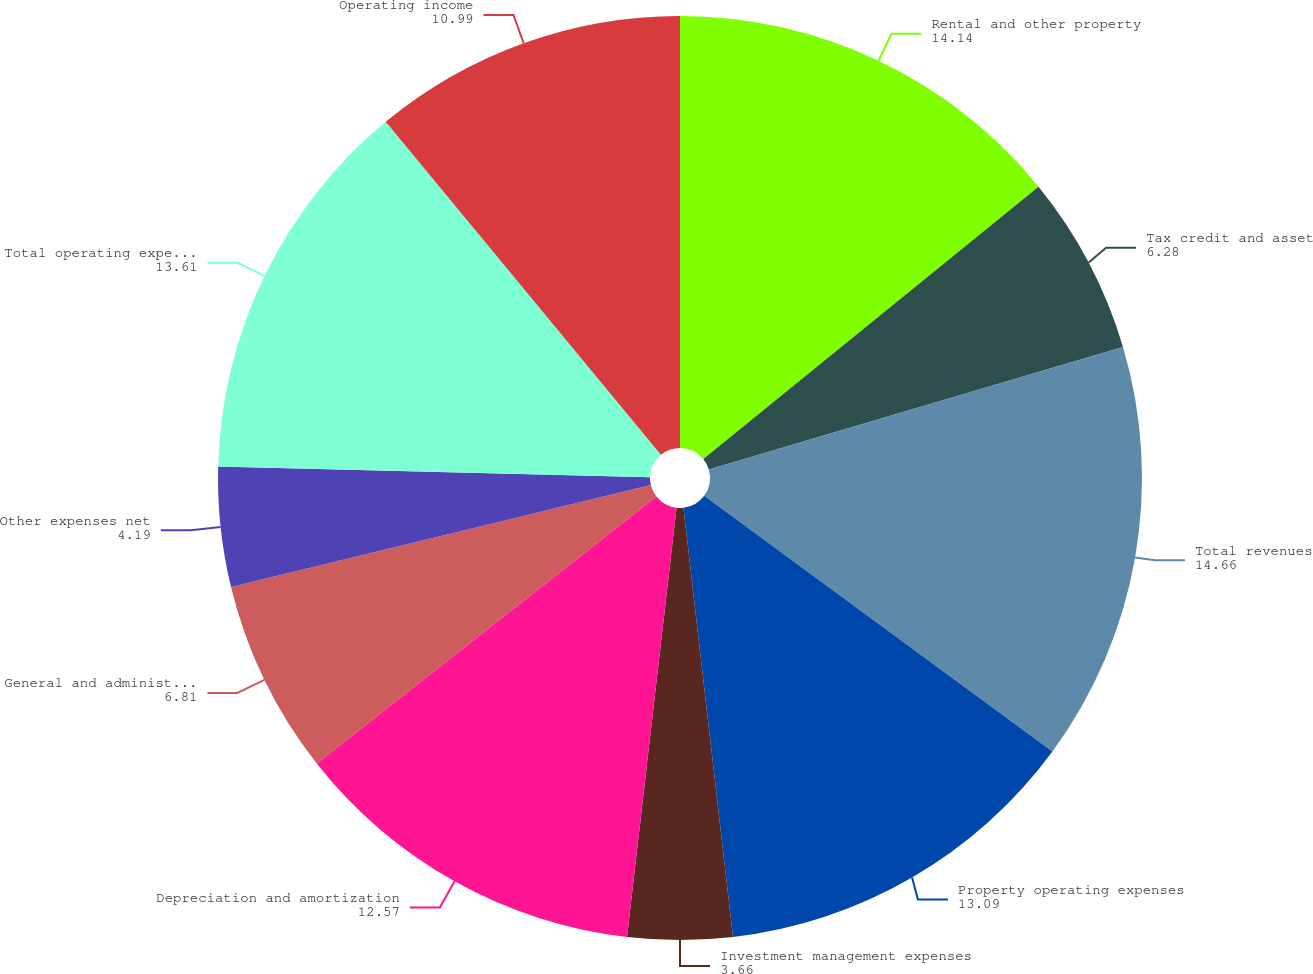Convert chart. <chart><loc_0><loc_0><loc_500><loc_500><pie_chart><fcel>Rental and other property<fcel>Tax credit and asset<fcel>Total revenues<fcel>Property operating expenses<fcel>Investment management expenses<fcel>Depreciation and amortization<fcel>General and administrative<fcel>Other expenses net<fcel>Total operating expenses<fcel>Operating income<nl><fcel>14.14%<fcel>6.28%<fcel>14.66%<fcel>13.09%<fcel>3.66%<fcel>12.57%<fcel>6.81%<fcel>4.19%<fcel>13.61%<fcel>10.99%<nl></chart> 